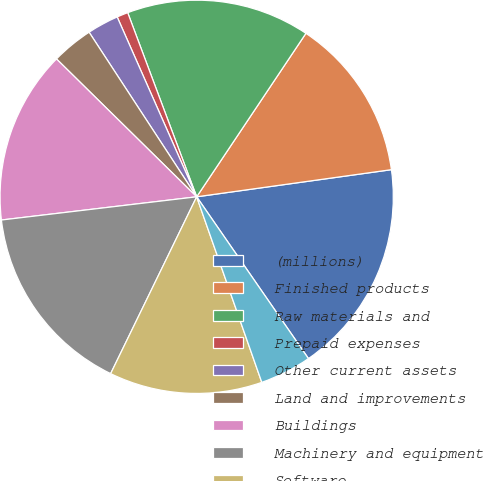Convert chart to OTSL. <chart><loc_0><loc_0><loc_500><loc_500><pie_chart><fcel>(millions)<fcel>Finished products<fcel>Raw materials and<fcel>Prepaid expenses<fcel>Other current assets<fcel>Land and improvements<fcel>Buildings<fcel>Machinery and equipment<fcel>Software<fcel>Construction-in-progress<nl><fcel>17.58%<fcel>13.42%<fcel>15.08%<fcel>0.92%<fcel>2.59%<fcel>3.42%<fcel>14.25%<fcel>15.91%<fcel>12.58%<fcel>4.25%<nl></chart> 